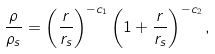Convert formula to latex. <formula><loc_0><loc_0><loc_500><loc_500>\frac { \rho } { \rho _ { s } } = \left ( \frac { r } { r _ { s } } \right ) ^ { - c _ { 1 } } \left ( 1 + \frac { r } { r _ { s } } \right ) ^ { - c _ { 2 } } ,</formula> 